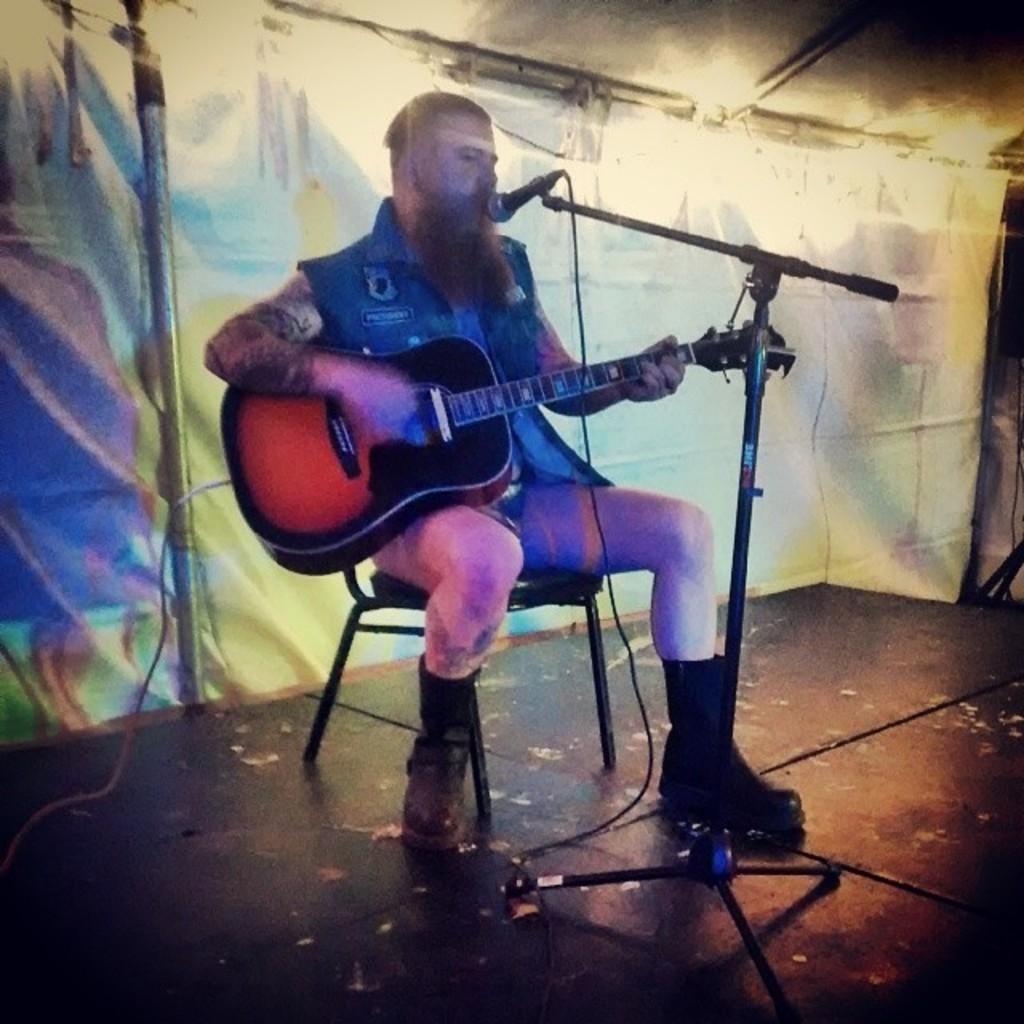Describe this image in one or two sentences. In this picture there is a man sitting on the chair playing a guitar and singing a song. In the background there is a curtain. 